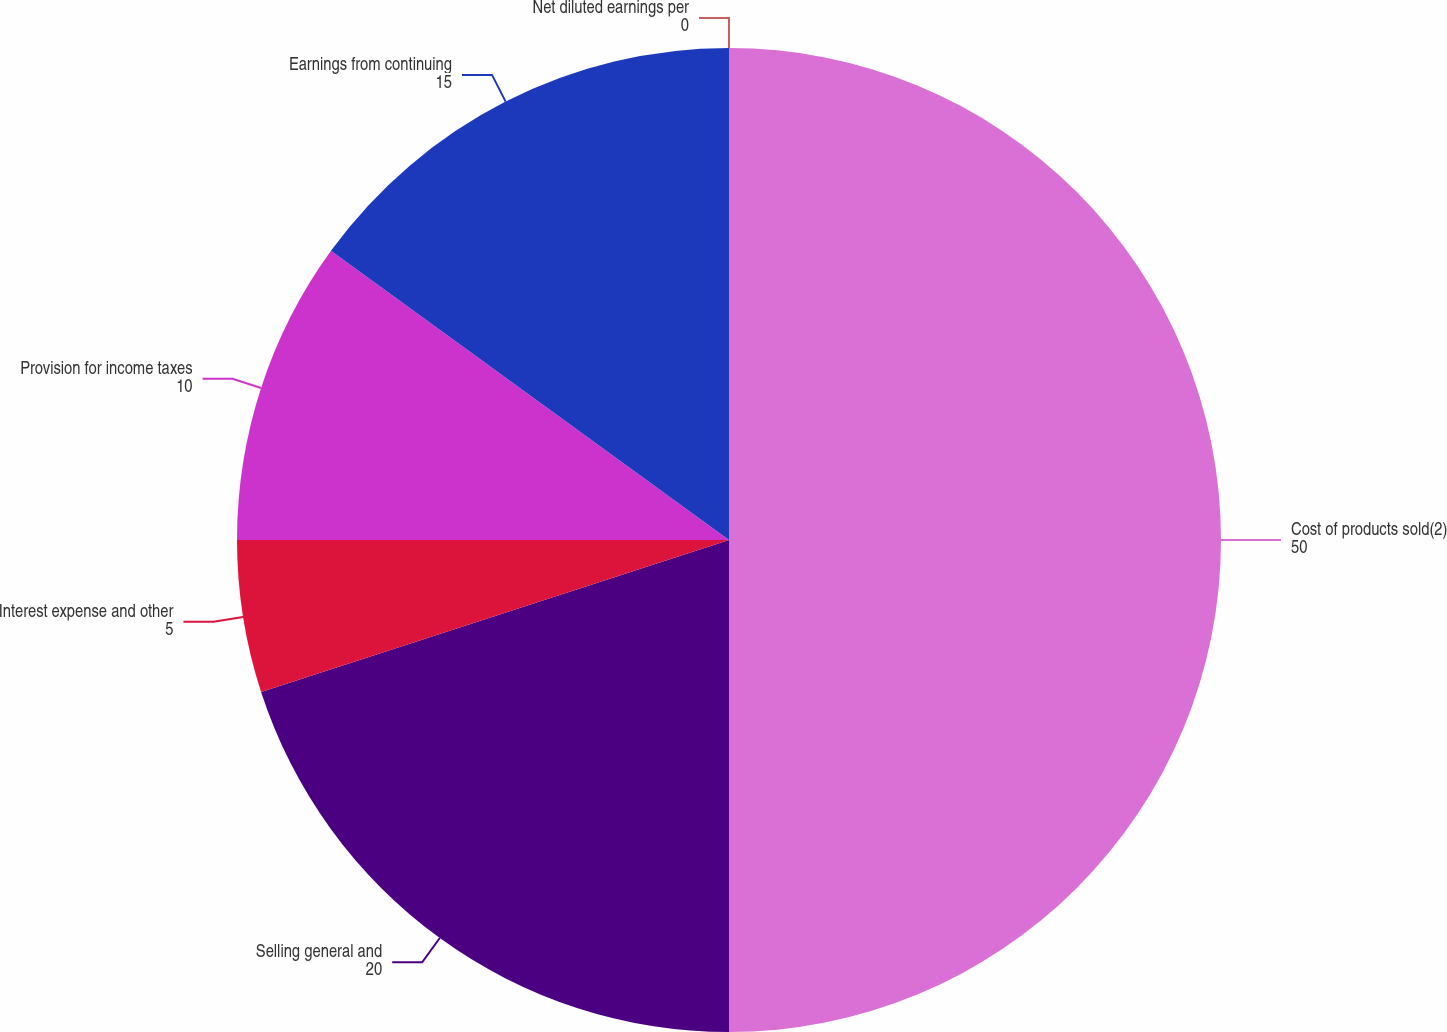<chart> <loc_0><loc_0><loc_500><loc_500><pie_chart><fcel>Cost of products sold(2)<fcel>Selling general and<fcel>Interest expense and other<fcel>Provision for income taxes<fcel>Earnings from continuing<fcel>Net diluted earnings per<nl><fcel>50.0%<fcel>20.0%<fcel>5.0%<fcel>10.0%<fcel>15.0%<fcel>0.0%<nl></chart> 